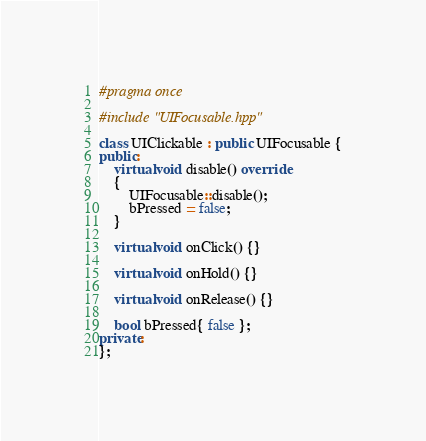<code> <loc_0><loc_0><loc_500><loc_500><_C++_>#pragma once

#include "UIFocusable.hpp"

class UIClickable : public UIFocusable {
public:
	virtual void disable() override
	{
		UIFocusable::disable();
		bPressed = false;
	}

	virtual void onClick() {}

	virtual void onHold() {}

	virtual void onRelease() {}

	bool bPressed{ false };
private:
};</code> 